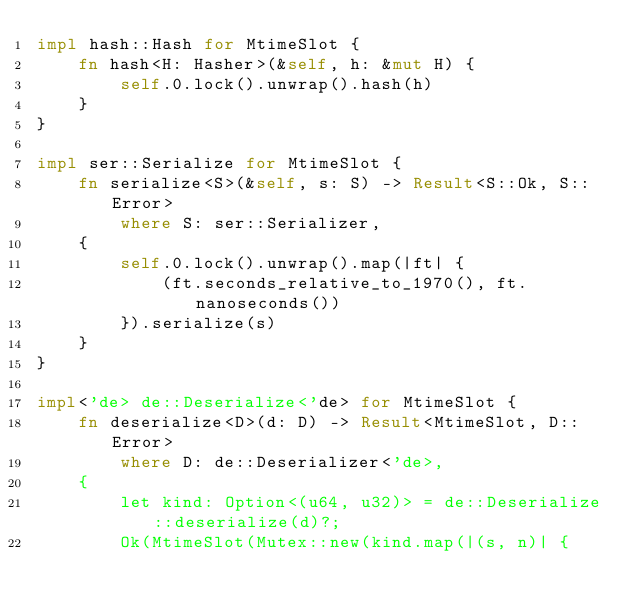<code> <loc_0><loc_0><loc_500><loc_500><_Rust_>impl hash::Hash for MtimeSlot {
    fn hash<H: Hasher>(&self, h: &mut H) {
        self.0.lock().unwrap().hash(h)
    }
}

impl ser::Serialize for MtimeSlot {
    fn serialize<S>(&self, s: S) -> Result<S::Ok, S::Error>
        where S: ser::Serializer,
    {
        self.0.lock().unwrap().map(|ft| {
            (ft.seconds_relative_to_1970(), ft.nanoseconds())
        }).serialize(s)
    }
}

impl<'de> de::Deserialize<'de> for MtimeSlot {
    fn deserialize<D>(d: D) -> Result<MtimeSlot, D::Error>
        where D: de::Deserializer<'de>,
    {
        let kind: Option<(u64, u32)> = de::Deserialize::deserialize(d)?;
        Ok(MtimeSlot(Mutex::new(kind.map(|(s, n)| {</code> 